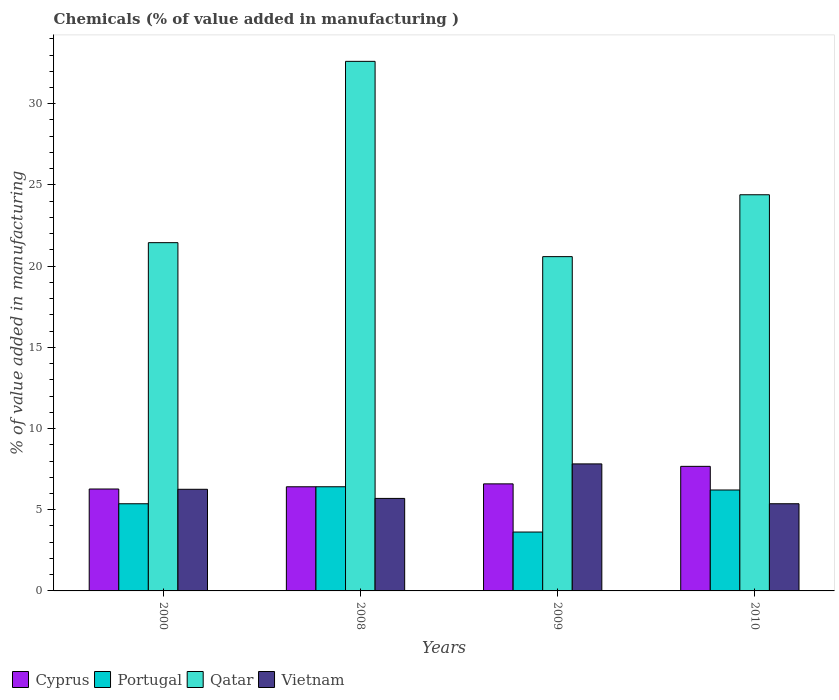Are the number of bars per tick equal to the number of legend labels?
Ensure brevity in your answer.  Yes. How many bars are there on the 4th tick from the left?
Provide a short and direct response. 4. How many bars are there on the 4th tick from the right?
Your answer should be compact. 4. In how many cases, is the number of bars for a given year not equal to the number of legend labels?
Your response must be concise. 0. What is the value added in manufacturing chemicals in Cyprus in 2000?
Offer a very short reply. 6.28. Across all years, what is the maximum value added in manufacturing chemicals in Cyprus?
Your answer should be very brief. 7.67. Across all years, what is the minimum value added in manufacturing chemicals in Cyprus?
Give a very brief answer. 6.28. What is the total value added in manufacturing chemicals in Portugal in the graph?
Give a very brief answer. 21.62. What is the difference between the value added in manufacturing chemicals in Qatar in 2008 and that in 2010?
Offer a terse response. 8.22. What is the difference between the value added in manufacturing chemicals in Portugal in 2008 and the value added in manufacturing chemicals in Vietnam in 2010?
Make the answer very short. 1.05. What is the average value added in manufacturing chemicals in Qatar per year?
Your response must be concise. 24.76. In the year 2000, what is the difference between the value added in manufacturing chemicals in Qatar and value added in manufacturing chemicals in Vietnam?
Ensure brevity in your answer.  15.19. In how many years, is the value added in manufacturing chemicals in Cyprus greater than 7 %?
Give a very brief answer. 1. What is the ratio of the value added in manufacturing chemicals in Portugal in 2000 to that in 2008?
Your answer should be very brief. 0.84. Is the value added in manufacturing chemicals in Cyprus in 2008 less than that in 2009?
Your answer should be compact. Yes. What is the difference between the highest and the second highest value added in manufacturing chemicals in Portugal?
Keep it short and to the point. 0.2. What is the difference between the highest and the lowest value added in manufacturing chemicals in Portugal?
Your answer should be compact. 2.79. In how many years, is the value added in manufacturing chemicals in Qatar greater than the average value added in manufacturing chemicals in Qatar taken over all years?
Keep it short and to the point. 1. Is it the case that in every year, the sum of the value added in manufacturing chemicals in Portugal and value added in manufacturing chemicals in Cyprus is greater than the sum of value added in manufacturing chemicals in Vietnam and value added in manufacturing chemicals in Qatar?
Your answer should be compact. No. What does the 2nd bar from the left in 2000 represents?
Your answer should be very brief. Portugal. What does the 2nd bar from the right in 2010 represents?
Provide a succinct answer. Qatar. How many bars are there?
Give a very brief answer. 16. Are all the bars in the graph horizontal?
Offer a terse response. No. Are the values on the major ticks of Y-axis written in scientific E-notation?
Your answer should be compact. No. How many legend labels are there?
Offer a very short reply. 4. What is the title of the graph?
Ensure brevity in your answer.  Chemicals (% of value added in manufacturing ). Does "Korea (Republic)" appear as one of the legend labels in the graph?
Your answer should be very brief. No. What is the label or title of the X-axis?
Provide a succinct answer. Years. What is the label or title of the Y-axis?
Keep it short and to the point. % of value added in manufacturing. What is the % of value added in manufacturing of Cyprus in 2000?
Your answer should be very brief. 6.28. What is the % of value added in manufacturing of Portugal in 2000?
Provide a short and direct response. 5.37. What is the % of value added in manufacturing of Qatar in 2000?
Your answer should be very brief. 21.45. What is the % of value added in manufacturing of Vietnam in 2000?
Provide a succinct answer. 6.26. What is the % of value added in manufacturing in Cyprus in 2008?
Offer a very short reply. 6.41. What is the % of value added in manufacturing of Portugal in 2008?
Offer a terse response. 6.41. What is the % of value added in manufacturing of Qatar in 2008?
Make the answer very short. 32.61. What is the % of value added in manufacturing of Vietnam in 2008?
Ensure brevity in your answer.  5.7. What is the % of value added in manufacturing of Cyprus in 2009?
Give a very brief answer. 6.59. What is the % of value added in manufacturing in Portugal in 2009?
Your answer should be compact. 3.63. What is the % of value added in manufacturing of Qatar in 2009?
Make the answer very short. 20.59. What is the % of value added in manufacturing in Vietnam in 2009?
Your answer should be compact. 7.82. What is the % of value added in manufacturing in Cyprus in 2010?
Offer a terse response. 7.67. What is the % of value added in manufacturing of Portugal in 2010?
Your response must be concise. 6.21. What is the % of value added in manufacturing in Qatar in 2010?
Offer a very short reply. 24.4. What is the % of value added in manufacturing in Vietnam in 2010?
Your answer should be compact. 5.37. Across all years, what is the maximum % of value added in manufacturing of Cyprus?
Your response must be concise. 7.67. Across all years, what is the maximum % of value added in manufacturing in Portugal?
Your answer should be compact. 6.41. Across all years, what is the maximum % of value added in manufacturing in Qatar?
Your answer should be very brief. 32.61. Across all years, what is the maximum % of value added in manufacturing of Vietnam?
Your answer should be very brief. 7.82. Across all years, what is the minimum % of value added in manufacturing of Cyprus?
Your answer should be compact. 6.28. Across all years, what is the minimum % of value added in manufacturing of Portugal?
Your answer should be compact. 3.63. Across all years, what is the minimum % of value added in manufacturing of Qatar?
Provide a short and direct response. 20.59. Across all years, what is the minimum % of value added in manufacturing of Vietnam?
Offer a terse response. 5.37. What is the total % of value added in manufacturing of Cyprus in the graph?
Offer a terse response. 26.95. What is the total % of value added in manufacturing in Portugal in the graph?
Provide a succinct answer. 21.62. What is the total % of value added in manufacturing in Qatar in the graph?
Your answer should be very brief. 99.04. What is the total % of value added in manufacturing of Vietnam in the graph?
Give a very brief answer. 25.15. What is the difference between the % of value added in manufacturing of Cyprus in 2000 and that in 2008?
Give a very brief answer. -0.14. What is the difference between the % of value added in manufacturing of Portugal in 2000 and that in 2008?
Your answer should be very brief. -1.05. What is the difference between the % of value added in manufacturing of Qatar in 2000 and that in 2008?
Keep it short and to the point. -11.16. What is the difference between the % of value added in manufacturing of Vietnam in 2000 and that in 2008?
Provide a succinct answer. 0.56. What is the difference between the % of value added in manufacturing of Cyprus in 2000 and that in 2009?
Keep it short and to the point. -0.32. What is the difference between the % of value added in manufacturing in Portugal in 2000 and that in 2009?
Ensure brevity in your answer.  1.74. What is the difference between the % of value added in manufacturing in Qatar in 2000 and that in 2009?
Give a very brief answer. 0.86. What is the difference between the % of value added in manufacturing in Vietnam in 2000 and that in 2009?
Keep it short and to the point. -1.56. What is the difference between the % of value added in manufacturing in Cyprus in 2000 and that in 2010?
Give a very brief answer. -1.39. What is the difference between the % of value added in manufacturing of Portugal in 2000 and that in 2010?
Offer a very short reply. -0.85. What is the difference between the % of value added in manufacturing of Qatar in 2000 and that in 2010?
Your response must be concise. -2.95. What is the difference between the % of value added in manufacturing in Vietnam in 2000 and that in 2010?
Provide a short and direct response. 0.89. What is the difference between the % of value added in manufacturing in Cyprus in 2008 and that in 2009?
Offer a very short reply. -0.18. What is the difference between the % of value added in manufacturing in Portugal in 2008 and that in 2009?
Give a very brief answer. 2.79. What is the difference between the % of value added in manufacturing in Qatar in 2008 and that in 2009?
Ensure brevity in your answer.  12.03. What is the difference between the % of value added in manufacturing of Vietnam in 2008 and that in 2009?
Give a very brief answer. -2.13. What is the difference between the % of value added in manufacturing of Cyprus in 2008 and that in 2010?
Make the answer very short. -1.26. What is the difference between the % of value added in manufacturing in Portugal in 2008 and that in 2010?
Offer a terse response. 0.2. What is the difference between the % of value added in manufacturing in Qatar in 2008 and that in 2010?
Ensure brevity in your answer.  8.22. What is the difference between the % of value added in manufacturing of Vietnam in 2008 and that in 2010?
Provide a short and direct response. 0.33. What is the difference between the % of value added in manufacturing of Cyprus in 2009 and that in 2010?
Your response must be concise. -1.08. What is the difference between the % of value added in manufacturing of Portugal in 2009 and that in 2010?
Your answer should be compact. -2.59. What is the difference between the % of value added in manufacturing in Qatar in 2009 and that in 2010?
Your answer should be very brief. -3.81. What is the difference between the % of value added in manufacturing in Vietnam in 2009 and that in 2010?
Your response must be concise. 2.45. What is the difference between the % of value added in manufacturing in Cyprus in 2000 and the % of value added in manufacturing in Portugal in 2008?
Your answer should be very brief. -0.14. What is the difference between the % of value added in manufacturing in Cyprus in 2000 and the % of value added in manufacturing in Qatar in 2008?
Provide a short and direct response. -26.33. What is the difference between the % of value added in manufacturing of Cyprus in 2000 and the % of value added in manufacturing of Vietnam in 2008?
Offer a terse response. 0.58. What is the difference between the % of value added in manufacturing of Portugal in 2000 and the % of value added in manufacturing of Qatar in 2008?
Keep it short and to the point. -27.24. What is the difference between the % of value added in manufacturing of Portugal in 2000 and the % of value added in manufacturing of Vietnam in 2008?
Give a very brief answer. -0.33. What is the difference between the % of value added in manufacturing in Qatar in 2000 and the % of value added in manufacturing in Vietnam in 2008?
Provide a succinct answer. 15.75. What is the difference between the % of value added in manufacturing of Cyprus in 2000 and the % of value added in manufacturing of Portugal in 2009?
Provide a short and direct response. 2.65. What is the difference between the % of value added in manufacturing in Cyprus in 2000 and the % of value added in manufacturing in Qatar in 2009?
Your response must be concise. -14.31. What is the difference between the % of value added in manufacturing in Cyprus in 2000 and the % of value added in manufacturing in Vietnam in 2009?
Offer a terse response. -1.55. What is the difference between the % of value added in manufacturing in Portugal in 2000 and the % of value added in manufacturing in Qatar in 2009?
Provide a short and direct response. -15.22. What is the difference between the % of value added in manufacturing of Portugal in 2000 and the % of value added in manufacturing of Vietnam in 2009?
Your response must be concise. -2.45. What is the difference between the % of value added in manufacturing of Qatar in 2000 and the % of value added in manufacturing of Vietnam in 2009?
Give a very brief answer. 13.62. What is the difference between the % of value added in manufacturing of Cyprus in 2000 and the % of value added in manufacturing of Portugal in 2010?
Your answer should be compact. 0.06. What is the difference between the % of value added in manufacturing in Cyprus in 2000 and the % of value added in manufacturing in Qatar in 2010?
Make the answer very short. -18.12. What is the difference between the % of value added in manufacturing in Cyprus in 2000 and the % of value added in manufacturing in Vietnam in 2010?
Offer a terse response. 0.91. What is the difference between the % of value added in manufacturing in Portugal in 2000 and the % of value added in manufacturing in Qatar in 2010?
Make the answer very short. -19.03. What is the difference between the % of value added in manufacturing in Portugal in 2000 and the % of value added in manufacturing in Vietnam in 2010?
Ensure brevity in your answer.  -0. What is the difference between the % of value added in manufacturing in Qatar in 2000 and the % of value added in manufacturing in Vietnam in 2010?
Give a very brief answer. 16.08. What is the difference between the % of value added in manufacturing of Cyprus in 2008 and the % of value added in manufacturing of Portugal in 2009?
Give a very brief answer. 2.79. What is the difference between the % of value added in manufacturing in Cyprus in 2008 and the % of value added in manufacturing in Qatar in 2009?
Ensure brevity in your answer.  -14.17. What is the difference between the % of value added in manufacturing of Cyprus in 2008 and the % of value added in manufacturing of Vietnam in 2009?
Offer a terse response. -1.41. What is the difference between the % of value added in manufacturing in Portugal in 2008 and the % of value added in manufacturing in Qatar in 2009?
Provide a short and direct response. -14.17. What is the difference between the % of value added in manufacturing in Portugal in 2008 and the % of value added in manufacturing in Vietnam in 2009?
Keep it short and to the point. -1.41. What is the difference between the % of value added in manufacturing in Qatar in 2008 and the % of value added in manufacturing in Vietnam in 2009?
Ensure brevity in your answer.  24.79. What is the difference between the % of value added in manufacturing of Cyprus in 2008 and the % of value added in manufacturing of Portugal in 2010?
Make the answer very short. 0.2. What is the difference between the % of value added in manufacturing in Cyprus in 2008 and the % of value added in manufacturing in Qatar in 2010?
Your answer should be compact. -17.98. What is the difference between the % of value added in manufacturing of Cyprus in 2008 and the % of value added in manufacturing of Vietnam in 2010?
Your answer should be compact. 1.05. What is the difference between the % of value added in manufacturing in Portugal in 2008 and the % of value added in manufacturing in Qatar in 2010?
Offer a terse response. -17.98. What is the difference between the % of value added in manufacturing in Portugal in 2008 and the % of value added in manufacturing in Vietnam in 2010?
Offer a very short reply. 1.05. What is the difference between the % of value added in manufacturing of Qatar in 2008 and the % of value added in manufacturing of Vietnam in 2010?
Your answer should be very brief. 27.24. What is the difference between the % of value added in manufacturing in Cyprus in 2009 and the % of value added in manufacturing in Portugal in 2010?
Your answer should be very brief. 0.38. What is the difference between the % of value added in manufacturing in Cyprus in 2009 and the % of value added in manufacturing in Qatar in 2010?
Your answer should be very brief. -17.8. What is the difference between the % of value added in manufacturing of Cyprus in 2009 and the % of value added in manufacturing of Vietnam in 2010?
Make the answer very short. 1.22. What is the difference between the % of value added in manufacturing in Portugal in 2009 and the % of value added in manufacturing in Qatar in 2010?
Keep it short and to the point. -20.77. What is the difference between the % of value added in manufacturing of Portugal in 2009 and the % of value added in manufacturing of Vietnam in 2010?
Offer a very short reply. -1.74. What is the difference between the % of value added in manufacturing in Qatar in 2009 and the % of value added in manufacturing in Vietnam in 2010?
Your answer should be compact. 15.22. What is the average % of value added in manufacturing of Cyprus per year?
Keep it short and to the point. 6.74. What is the average % of value added in manufacturing of Portugal per year?
Ensure brevity in your answer.  5.41. What is the average % of value added in manufacturing of Qatar per year?
Your answer should be very brief. 24.76. What is the average % of value added in manufacturing of Vietnam per year?
Offer a terse response. 6.29. In the year 2000, what is the difference between the % of value added in manufacturing in Cyprus and % of value added in manufacturing in Portugal?
Keep it short and to the point. 0.91. In the year 2000, what is the difference between the % of value added in manufacturing of Cyprus and % of value added in manufacturing of Qatar?
Make the answer very short. -15.17. In the year 2000, what is the difference between the % of value added in manufacturing in Cyprus and % of value added in manufacturing in Vietnam?
Ensure brevity in your answer.  0.02. In the year 2000, what is the difference between the % of value added in manufacturing in Portugal and % of value added in manufacturing in Qatar?
Offer a terse response. -16.08. In the year 2000, what is the difference between the % of value added in manufacturing of Portugal and % of value added in manufacturing of Vietnam?
Make the answer very short. -0.89. In the year 2000, what is the difference between the % of value added in manufacturing of Qatar and % of value added in manufacturing of Vietnam?
Provide a succinct answer. 15.19. In the year 2008, what is the difference between the % of value added in manufacturing of Cyprus and % of value added in manufacturing of Portugal?
Your response must be concise. -0. In the year 2008, what is the difference between the % of value added in manufacturing in Cyprus and % of value added in manufacturing in Qatar?
Give a very brief answer. -26.2. In the year 2008, what is the difference between the % of value added in manufacturing in Cyprus and % of value added in manufacturing in Vietnam?
Provide a succinct answer. 0.72. In the year 2008, what is the difference between the % of value added in manufacturing of Portugal and % of value added in manufacturing of Qatar?
Keep it short and to the point. -26.2. In the year 2008, what is the difference between the % of value added in manufacturing of Portugal and % of value added in manufacturing of Vietnam?
Provide a succinct answer. 0.72. In the year 2008, what is the difference between the % of value added in manufacturing in Qatar and % of value added in manufacturing in Vietnam?
Ensure brevity in your answer.  26.91. In the year 2009, what is the difference between the % of value added in manufacturing of Cyprus and % of value added in manufacturing of Portugal?
Make the answer very short. 2.97. In the year 2009, what is the difference between the % of value added in manufacturing in Cyprus and % of value added in manufacturing in Qatar?
Keep it short and to the point. -13.99. In the year 2009, what is the difference between the % of value added in manufacturing of Cyprus and % of value added in manufacturing of Vietnam?
Offer a very short reply. -1.23. In the year 2009, what is the difference between the % of value added in manufacturing in Portugal and % of value added in manufacturing in Qatar?
Make the answer very short. -16.96. In the year 2009, what is the difference between the % of value added in manufacturing of Portugal and % of value added in manufacturing of Vietnam?
Ensure brevity in your answer.  -4.2. In the year 2009, what is the difference between the % of value added in manufacturing of Qatar and % of value added in manufacturing of Vietnam?
Ensure brevity in your answer.  12.76. In the year 2010, what is the difference between the % of value added in manufacturing in Cyprus and % of value added in manufacturing in Portugal?
Your answer should be very brief. 1.46. In the year 2010, what is the difference between the % of value added in manufacturing in Cyprus and % of value added in manufacturing in Qatar?
Make the answer very short. -16.72. In the year 2010, what is the difference between the % of value added in manufacturing in Cyprus and % of value added in manufacturing in Vietnam?
Offer a very short reply. 2.3. In the year 2010, what is the difference between the % of value added in manufacturing in Portugal and % of value added in manufacturing in Qatar?
Your response must be concise. -18.18. In the year 2010, what is the difference between the % of value added in manufacturing in Portugal and % of value added in manufacturing in Vietnam?
Ensure brevity in your answer.  0.85. In the year 2010, what is the difference between the % of value added in manufacturing in Qatar and % of value added in manufacturing in Vietnam?
Ensure brevity in your answer.  19.03. What is the ratio of the % of value added in manufacturing in Cyprus in 2000 to that in 2008?
Make the answer very short. 0.98. What is the ratio of the % of value added in manufacturing of Portugal in 2000 to that in 2008?
Your response must be concise. 0.84. What is the ratio of the % of value added in manufacturing of Qatar in 2000 to that in 2008?
Your answer should be very brief. 0.66. What is the ratio of the % of value added in manufacturing in Vietnam in 2000 to that in 2008?
Provide a succinct answer. 1.1. What is the ratio of the % of value added in manufacturing in Cyprus in 2000 to that in 2009?
Offer a very short reply. 0.95. What is the ratio of the % of value added in manufacturing in Portugal in 2000 to that in 2009?
Make the answer very short. 1.48. What is the ratio of the % of value added in manufacturing in Qatar in 2000 to that in 2009?
Your answer should be compact. 1.04. What is the ratio of the % of value added in manufacturing in Vietnam in 2000 to that in 2009?
Provide a succinct answer. 0.8. What is the ratio of the % of value added in manufacturing of Cyprus in 2000 to that in 2010?
Ensure brevity in your answer.  0.82. What is the ratio of the % of value added in manufacturing of Portugal in 2000 to that in 2010?
Provide a succinct answer. 0.86. What is the ratio of the % of value added in manufacturing of Qatar in 2000 to that in 2010?
Offer a terse response. 0.88. What is the ratio of the % of value added in manufacturing of Vietnam in 2000 to that in 2010?
Your answer should be compact. 1.17. What is the ratio of the % of value added in manufacturing of Cyprus in 2008 to that in 2009?
Offer a terse response. 0.97. What is the ratio of the % of value added in manufacturing of Portugal in 2008 to that in 2009?
Provide a short and direct response. 1.77. What is the ratio of the % of value added in manufacturing in Qatar in 2008 to that in 2009?
Give a very brief answer. 1.58. What is the ratio of the % of value added in manufacturing in Vietnam in 2008 to that in 2009?
Your response must be concise. 0.73. What is the ratio of the % of value added in manufacturing of Cyprus in 2008 to that in 2010?
Keep it short and to the point. 0.84. What is the ratio of the % of value added in manufacturing in Portugal in 2008 to that in 2010?
Offer a terse response. 1.03. What is the ratio of the % of value added in manufacturing in Qatar in 2008 to that in 2010?
Give a very brief answer. 1.34. What is the ratio of the % of value added in manufacturing in Vietnam in 2008 to that in 2010?
Provide a succinct answer. 1.06. What is the ratio of the % of value added in manufacturing of Cyprus in 2009 to that in 2010?
Ensure brevity in your answer.  0.86. What is the ratio of the % of value added in manufacturing in Portugal in 2009 to that in 2010?
Ensure brevity in your answer.  0.58. What is the ratio of the % of value added in manufacturing of Qatar in 2009 to that in 2010?
Your answer should be very brief. 0.84. What is the ratio of the % of value added in manufacturing in Vietnam in 2009 to that in 2010?
Provide a succinct answer. 1.46. What is the difference between the highest and the second highest % of value added in manufacturing in Cyprus?
Provide a succinct answer. 1.08. What is the difference between the highest and the second highest % of value added in manufacturing of Portugal?
Give a very brief answer. 0.2. What is the difference between the highest and the second highest % of value added in manufacturing in Qatar?
Give a very brief answer. 8.22. What is the difference between the highest and the second highest % of value added in manufacturing in Vietnam?
Ensure brevity in your answer.  1.56. What is the difference between the highest and the lowest % of value added in manufacturing of Cyprus?
Give a very brief answer. 1.39. What is the difference between the highest and the lowest % of value added in manufacturing in Portugal?
Make the answer very short. 2.79. What is the difference between the highest and the lowest % of value added in manufacturing of Qatar?
Provide a succinct answer. 12.03. What is the difference between the highest and the lowest % of value added in manufacturing in Vietnam?
Make the answer very short. 2.45. 